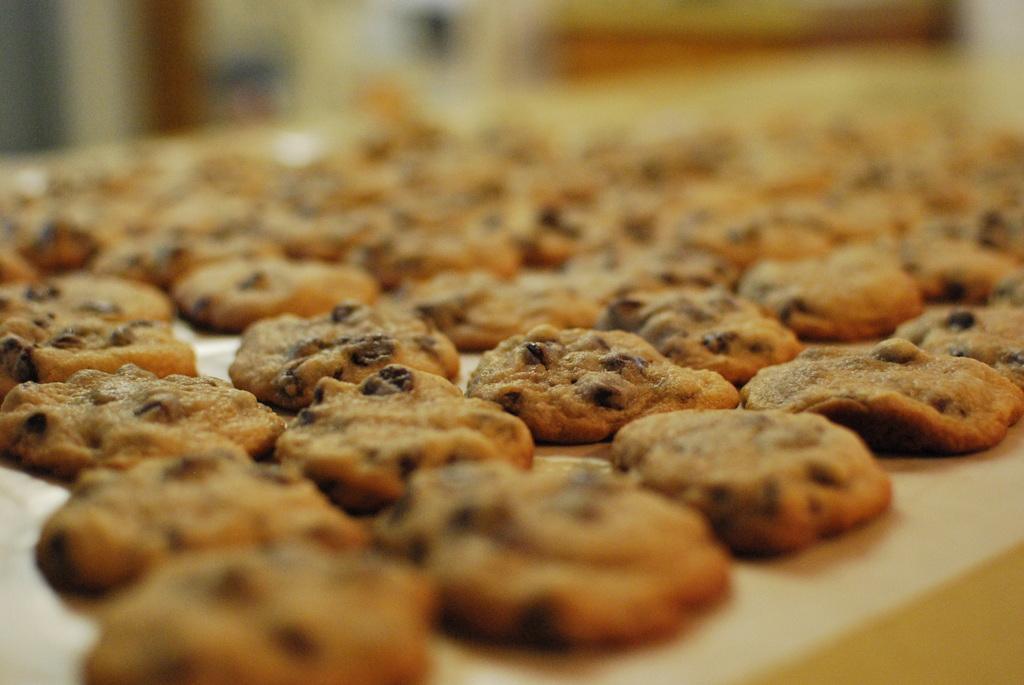Can you describe this image briefly? In this image we can see cookies placed on the tray. 